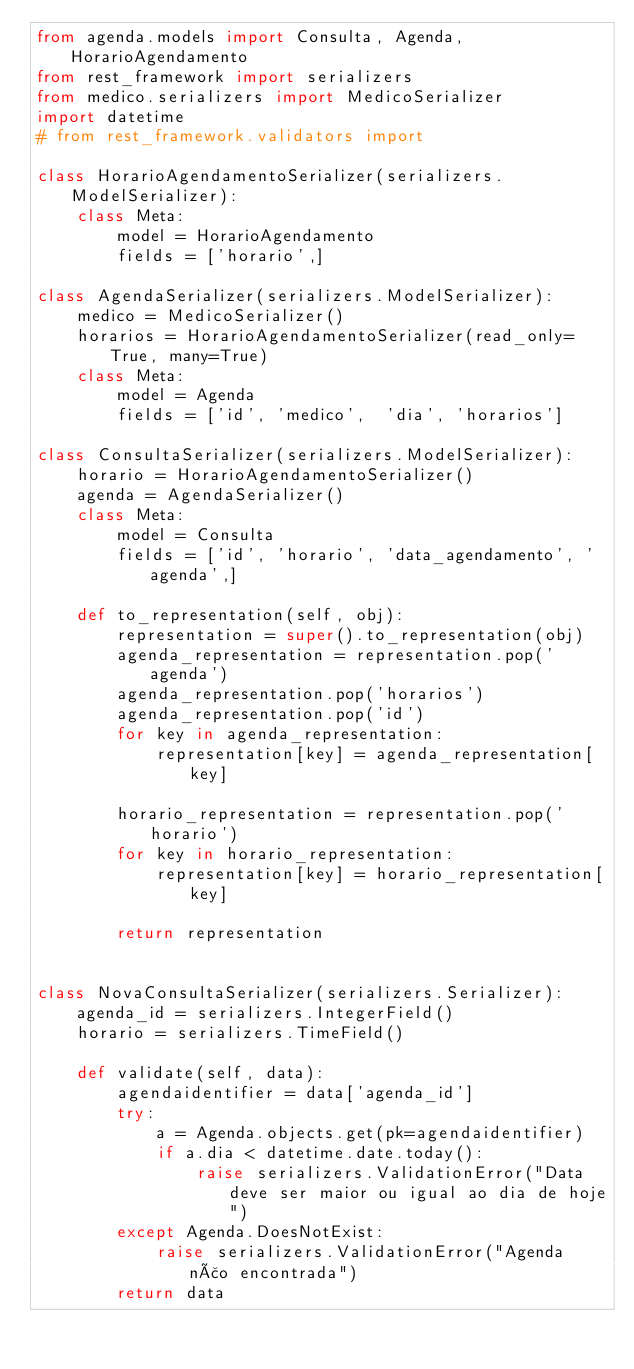Convert code to text. <code><loc_0><loc_0><loc_500><loc_500><_Python_>from agenda.models import Consulta, Agenda, HorarioAgendamento
from rest_framework import serializers
from medico.serializers import MedicoSerializer
import datetime
# from rest_framework.validators import 

class HorarioAgendamentoSerializer(serializers.ModelSerializer):
    class Meta:
        model = HorarioAgendamento
        fields = ['horario',]

class AgendaSerializer(serializers.ModelSerializer):
    medico = MedicoSerializer()
    horarios = HorarioAgendamentoSerializer(read_only=True, many=True)
    class Meta:
        model = Agenda
        fields = ['id', 'medico',  'dia', 'horarios']

class ConsultaSerializer(serializers.ModelSerializer):
    horario = HorarioAgendamentoSerializer()
    agenda = AgendaSerializer()
    class Meta:
        model = Consulta
        fields = ['id', 'horario', 'data_agendamento', 'agenda',]

    def to_representation(self, obj):
        representation = super().to_representation(obj)
        agenda_representation = representation.pop('agenda')
        agenda_representation.pop('horarios')
        agenda_representation.pop('id')
        for key in agenda_representation:
            representation[key] = agenda_representation[key]

        horario_representation = representation.pop('horario')
        for key in horario_representation:
            representation[key] = horario_representation[key]

        return representation


class NovaConsultaSerializer(serializers.Serializer):
    agenda_id = serializers.IntegerField()
    horario = serializers.TimeField()

    def validate(self, data):
        agendaidentifier = data['agenda_id']
        try:
            a = Agenda.objects.get(pk=agendaidentifier)
            if a.dia < datetime.date.today():
                raise serializers.ValidationError("Data deve ser maior ou igual ao dia de hoje")
        except Agenda.DoesNotExist:
            raise serializers.ValidationError("Agenda não encontrada")
        return data</code> 